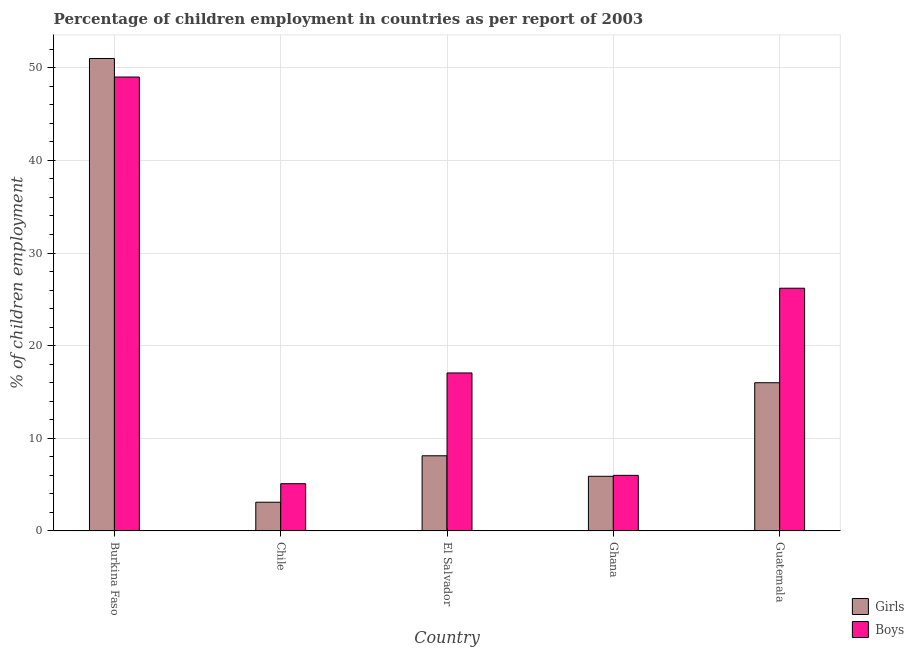How many groups of bars are there?
Ensure brevity in your answer.  5. Are the number of bars on each tick of the X-axis equal?
Keep it short and to the point. Yes. How many bars are there on the 4th tick from the left?
Your response must be concise. 2. What is the label of the 4th group of bars from the left?
Ensure brevity in your answer.  Ghana. What is the percentage of employed boys in El Salvador?
Your response must be concise. 17.06. Across all countries, what is the maximum percentage of employed boys?
Offer a very short reply. 49. Across all countries, what is the minimum percentage of employed boys?
Give a very brief answer. 5.1. In which country was the percentage of employed girls maximum?
Your answer should be compact. Burkina Faso. In which country was the percentage of employed boys minimum?
Provide a short and direct response. Chile. What is the total percentage of employed boys in the graph?
Keep it short and to the point. 103.36. What is the difference between the percentage of employed boys in Ghana and that in Guatemala?
Keep it short and to the point. -20.2. What is the difference between the percentage of employed girls in Burkina Faso and the percentage of employed boys in Ghana?
Offer a very short reply. 45. What is the average percentage of employed girls per country?
Provide a short and direct response. 16.82. What is the difference between the percentage of employed girls and percentage of employed boys in Chile?
Offer a very short reply. -2. In how many countries, is the percentage of employed boys greater than 42 %?
Offer a very short reply. 1. What is the ratio of the percentage of employed girls in Burkina Faso to that in Guatemala?
Keep it short and to the point. 3.19. Is the difference between the percentage of employed girls in Chile and Ghana greater than the difference between the percentage of employed boys in Chile and Ghana?
Offer a terse response. No. What is the difference between the highest and the second highest percentage of employed girls?
Your response must be concise. 35. What is the difference between the highest and the lowest percentage of employed boys?
Keep it short and to the point. 43.9. What does the 1st bar from the left in Chile represents?
Ensure brevity in your answer.  Girls. What does the 2nd bar from the right in Burkina Faso represents?
Your answer should be very brief. Girls. How many bars are there?
Offer a very short reply. 10. Are all the bars in the graph horizontal?
Ensure brevity in your answer.  No. How many countries are there in the graph?
Your response must be concise. 5. What is the difference between two consecutive major ticks on the Y-axis?
Ensure brevity in your answer.  10. Are the values on the major ticks of Y-axis written in scientific E-notation?
Offer a very short reply. No. Does the graph contain grids?
Offer a very short reply. Yes. Where does the legend appear in the graph?
Your answer should be compact. Bottom right. How many legend labels are there?
Keep it short and to the point. 2. What is the title of the graph?
Provide a short and direct response. Percentage of children employment in countries as per report of 2003. Does "Methane" appear as one of the legend labels in the graph?
Keep it short and to the point. No. What is the label or title of the Y-axis?
Your answer should be very brief. % of children employment. What is the % of children employment in Boys in Burkina Faso?
Your response must be concise. 49. What is the % of children employment in Girls in Chile?
Offer a very short reply. 3.1. What is the % of children employment of Girls in El Salvador?
Your answer should be very brief. 8.11. What is the % of children employment in Boys in El Salvador?
Provide a succinct answer. 17.06. What is the % of children employment in Boys in Guatemala?
Keep it short and to the point. 26.2. Across all countries, what is the minimum % of children employment of Boys?
Your answer should be very brief. 5.1. What is the total % of children employment of Girls in the graph?
Ensure brevity in your answer.  84.11. What is the total % of children employment of Boys in the graph?
Your response must be concise. 103.36. What is the difference between the % of children employment of Girls in Burkina Faso and that in Chile?
Offer a terse response. 47.9. What is the difference between the % of children employment of Boys in Burkina Faso and that in Chile?
Keep it short and to the point. 43.9. What is the difference between the % of children employment of Girls in Burkina Faso and that in El Salvador?
Offer a terse response. 42.89. What is the difference between the % of children employment in Boys in Burkina Faso and that in El Salvador?
Your answer should be very brief. 31.94. What is the difference between the % of children employment in Girls in Burkina Faso and that in Ghana?
Offer a very short reply. 45.1. What is the difference between the % of children employment of Girls in Burkina Faso and that in Guatemala?
Your answer should be very brief. 35. What is the difference between the % of children employment in Boys in Burkina Faso and that in Guatemala?
Keep it short and to the point. 22.8. What is the difference between the % of children employment in Girls in Chile and that in El Salvador?
Ensure brevity in your answer.  -5.01. What is the difference between the % of children employment in Boys in Chile and that in El Salvador?
Offer a very short reply. -11.96. What is the difference between the % of children employment in Girls in Chile and that in Ghana?
Keep it short and to the point. -2.8. What is the difference between the % of children employment of Boys in Chile and that in Ghana?
Offer a very short reply. -0.9. What is the difference between the % of children employment of Boys in Chile and that in Guatemala?
Provide a succinct answer. -21.1. What is the difference between the % of children employment in Girls in El Salvador and that in Ghana?
Your answer should be compact. 2.21. What is the difference between the % of children employment in Boys in El Salvador and that in Ghana?
Offer a very short reply. 11.06. What is the difference between the % of children employment in Girls in El Salvador and that in Guatemala?
Provide a succinct answer. -7.89. What is the difference between the % of children employment of Boys in El Salvador and that in Guatemala?
Your response must be concise. -9.14. What is the difference between the % of children employment in Girls in Ghana and that in Guatemala?
Your answer should be compact. -10.1. What is the difference between the % of children employment of Boys in Ghana and that in Guatemala?
Your answer should be compact. -20.2. What is the difference between the % of children employment in Girls in Burkina Faso and the % of children employment in Boys in Chile?
Offer a very short reply. 45.9. What is the difference between the % of children employment of Girls in Burkina Faso and the % of children employment of Boys in El Salvador?
Provide a short and direct response. 33.94. What is the difference between the % of children employment in Girls in Burkina Faso and the % of children employment in Boys in Guatemala?
Give a very brief answer. 24.8. What is the difference between the % of children employment of Girls in Chile and the % of children employment of Boys in El Salvador?
Make the answer very short. -13.96. What is the difference between the % of children employment of Girls in Chile and the % of children employment of Boys in Ghana?
Provide a short and direct response. -2.9. What is the difference between the % of children employment of Girls in Chile and the % of children employment of Boys in Guatemala?
Make the answer very short. -23.1. What is the difference between the % of children employment of Girls in El Salvador and the % of children employment of Boys in Ghana?
Give a very brief answer. 2.11. What is the difference between the % of children employment in Girls in El Salvador and the % of children employment in Boys in Guatemala?
Your answer should be very brief. -18.09. What is the difference between the % of children employment of Girls in Ghana and the % of children employment of Boys in Guatemala?
Keep it short and to the point. -20.3. What is the average % of children employment in Girls per country?
Offer a very short reply. 16.82. What is the average % of children employment of Boys per country?
Offer a terse response. 20.67. What is the difference between the % of children employment in Girls and % of children employment in Boys in El Salvador?
Your answer should be compact. -8.94. What is the difference between the % of children employment of Girls and % of children employment of Boys in Ghana?
Provide a short and direct response. -0.1. What is the difference between the % of children employment in Girls and % of children employment in Boys in Guatemala?
Your answer should be very brief. -10.2. What is the ratio of the % of children employment in Girls in Burkina Faso to that in Chile?
Give a very brief answer. 16.45. What is the ratio of the % of children employment of Boys in Burkina Faso to that in Chile?
Keep it short and to the point. 9.61. What is the ratio of the % of children employment in Girls in Burkina Faso to that in El Salvador?
Provide a short and direct response. 6.29. What is the ratio of the % of children employment of Boys in Burkina Faso to that in El Salvador?
Make the answer very short. 2.87. What is the ratio of the % of children employment of Girls in Burkina Faso to that in Ghana?
Provide a succinct answer. 8.64. What is the ratio of the % of children employment of Boys in Burkina Faso to that in Ghana?
Provide a short and direct response. 8.17. What is the ratio of the % of children employment in Girls in Burkina Faso to that in Guatemala?
Make the answer very short. 3.19. What is the ratio of the % of children employment of Boys in Burkina Faso to that in Guatemala?
Your response must be concise. 1.87. What is the ratio of the % of children employment of Girls in Chile to that in El Salvador?
Give a very brief answer. 0.38. What is the ratio of the % of children employment of Boys in Chile to that in El Salvador?
Offer a very short reply. 0.3. What is the ratio of the % of children employment in Girls in Chile to that in Ghana?
Give a very brief answer. 0.53. What is the ratio of the % of children employment of Girls in Chile to that in Guatemala?
Make the answer very short. 0.19. What is the ratio of the % of children employment in Boys in Chile to that in Guatemala?
Ensure brevity in your answer.  0.19. What is the ratio of the % of children employment in Girls in El Salvador to that in Ghana?
Ensure brevity in your answer.  1.38. What is the ratio of the % of children employment of Boys in El Salvador to that in Ghana?
Give a very brief answer. 2.84. What is the ratio of the % of children employment in Girls in El Salvador to that in Guatemala?
Your answer should be compact. 0.51. What is the ratio of the % of children employment of Boys in El Salvador to that in Guatemala?
Ensure brevity in your answer.  0.65. What is the ratio of the % of children employment of Girls in Ghana to that in Guatemala?
Your answer should be very brief. 0.37. What is the ratio of the % of children employment of Boys in Ghana to that in Guatemala?
Your answer should be compact. 0.23. What is the difference between the highest and the second highest % of children employment in Boys?
Ensure brevity in your answer.  22.8. What is the difference between the highest and the lowest % of children employment of Girls?
Offer a very short reply. 47.9. What is the difference between the highest and the lowest % of children employment in Boys?
Offer a very short reply. 43.9. 